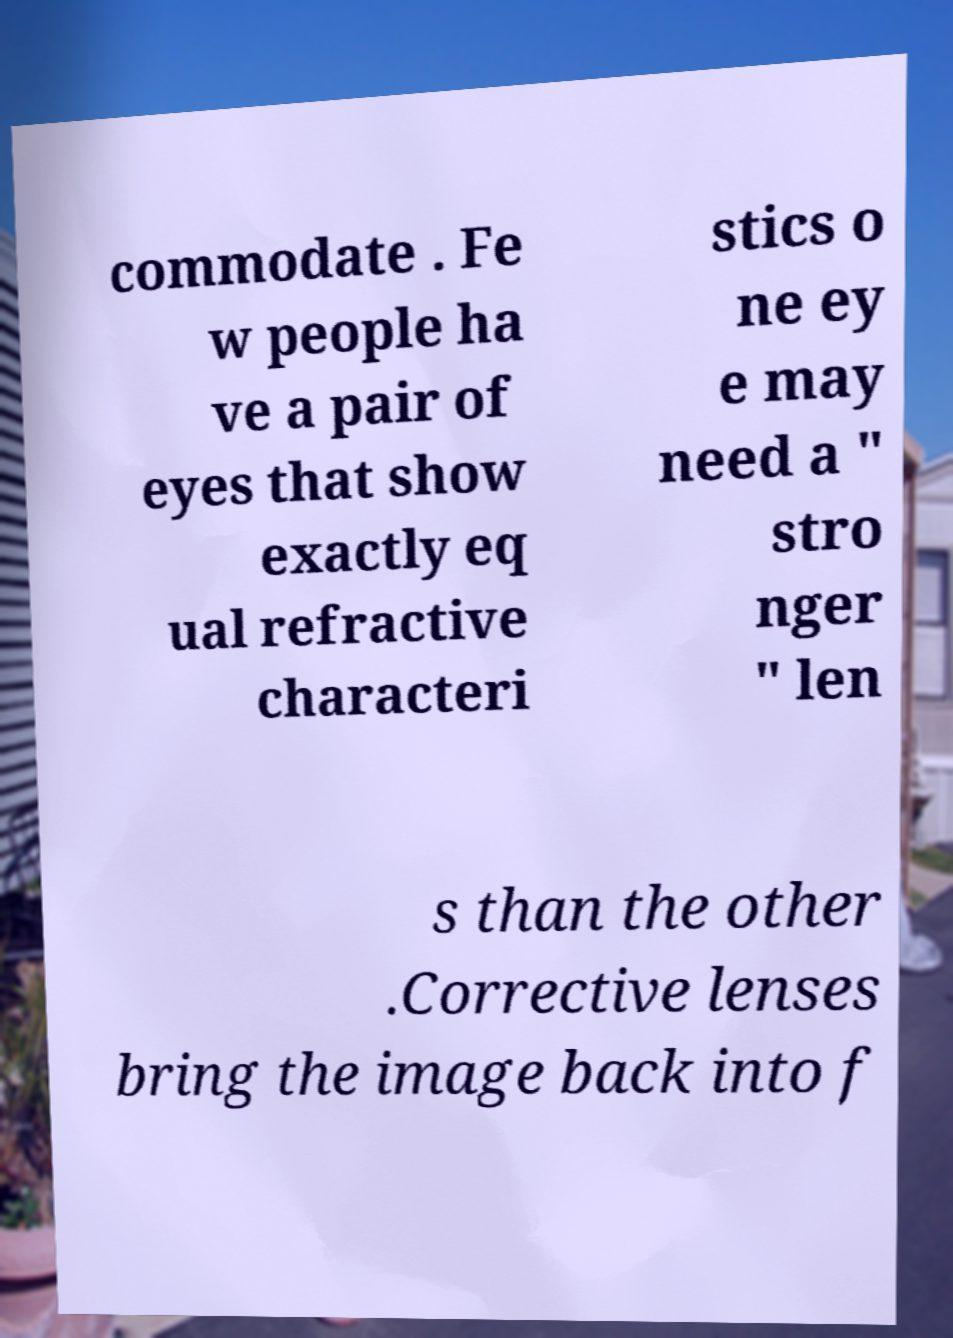There's text embedded in this image that I need extracted. Can you transcribe it verbatim? commodate . Fe w people ha ve a pair of eyes that show exactly eq ual refractive characteri stics o ne ey e may need a " stro nger " len s than the other .Corrective lenses bring the image back into f 